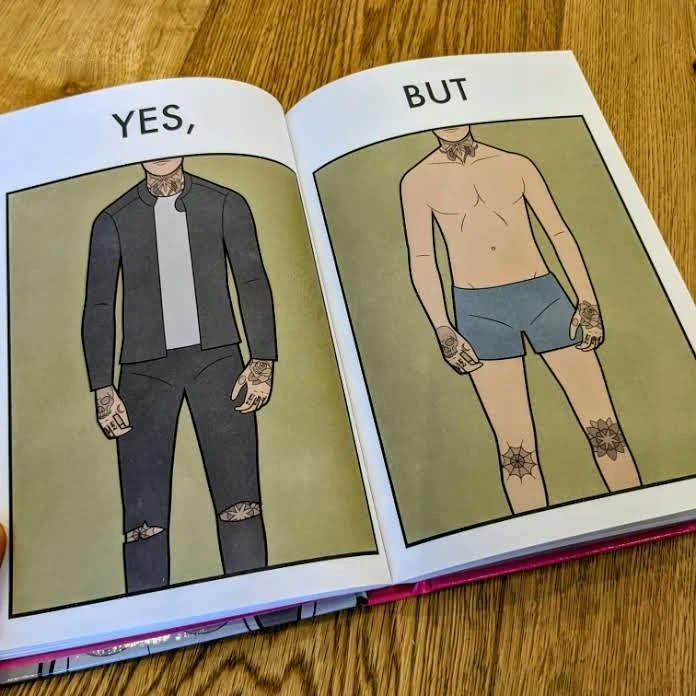Does this image contain satire or humor? Yes, this image is satirical. 